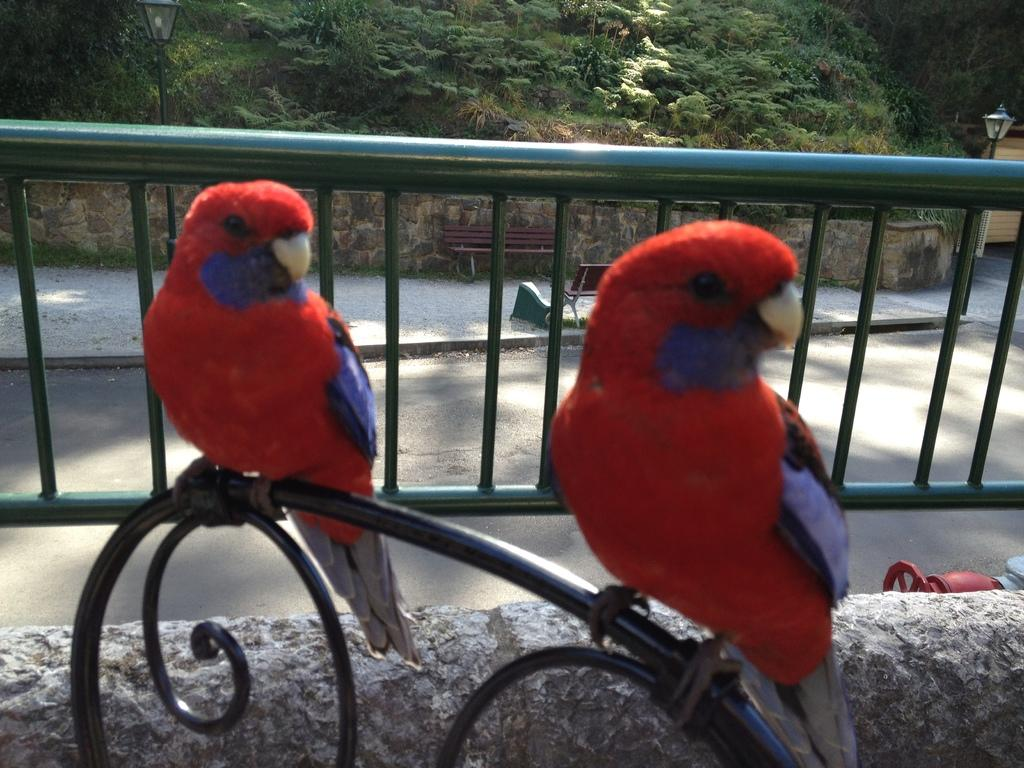What type of animals are on the wall in the image? There are parrots on the wall in the image. What is visible in the background of the image? There is a wall, benches, a road, a street light, and trees in the background of the image. What type of silk is being used to patch the grade in the image? There is no silk or grade present in the image. The image features parrots on a wall and various elements in the background, but no silk or grade is visible. 